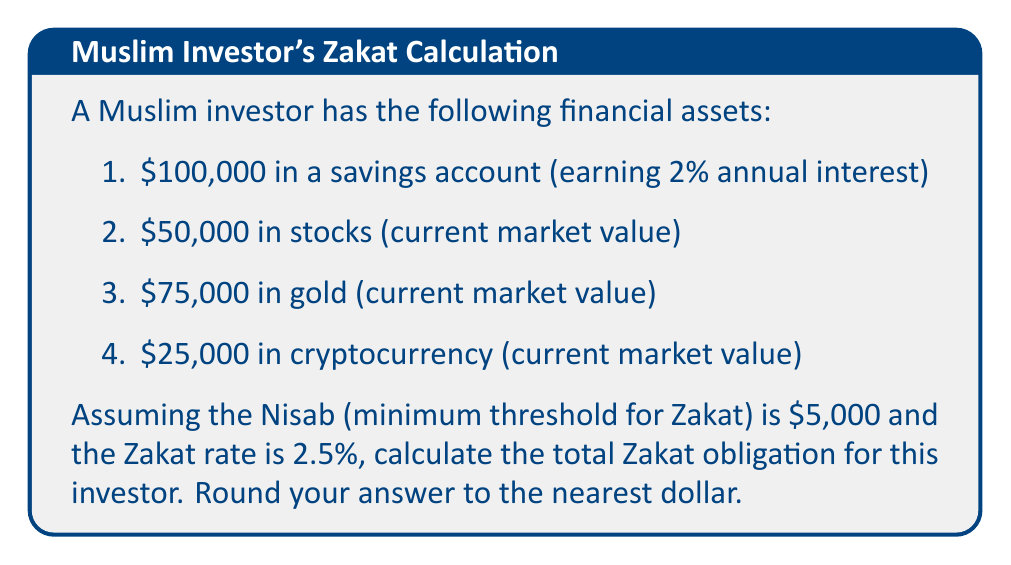Help me with this question. To calculate the Zakat obligation, we need to follow these steps:

1. Determine which assets are Zakatable:
   - Savings account: Zakatable
   - Stocks: Zakatable
   - Gold: Zakatable
   - Cryptocurrency: Zakatable (considered a form of wealth)

2. Calculate the total value of Zakatable assets:
   $$100,000 + 50,000 + 75,000 + 25,000 = $250,000$$

3. Check if the total value exceeds the Nisab:
   $250,000 > $5,000, so Zakat is due

4. Calculate the Zakat obligation:
   $$\text{Zakat} = \text{Total Zakatable Assets} \times \text{Zakat Rate}$$
   $$\text{Zakat} = $250,000 \times 2.5\% = $250,000 \times 0.025 = $6,250$$

5. Round to the nearest dollar:
   $6,250 (no rounding needed)

It's important to note that in Islamic finance, interest earned on savings is generally not considered permissible (haram). However, for the purpose of Zakat calculation, we include the full amount in the savings account, as it represents the total wealth possessed by the investor.
Answer: $6,250 